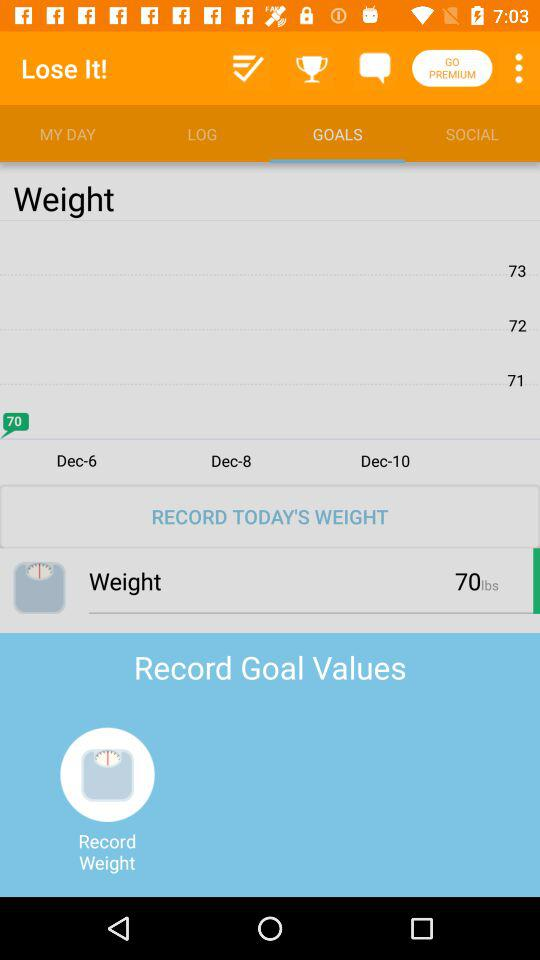What is the month for which the record is shown? The record is shown for December. 